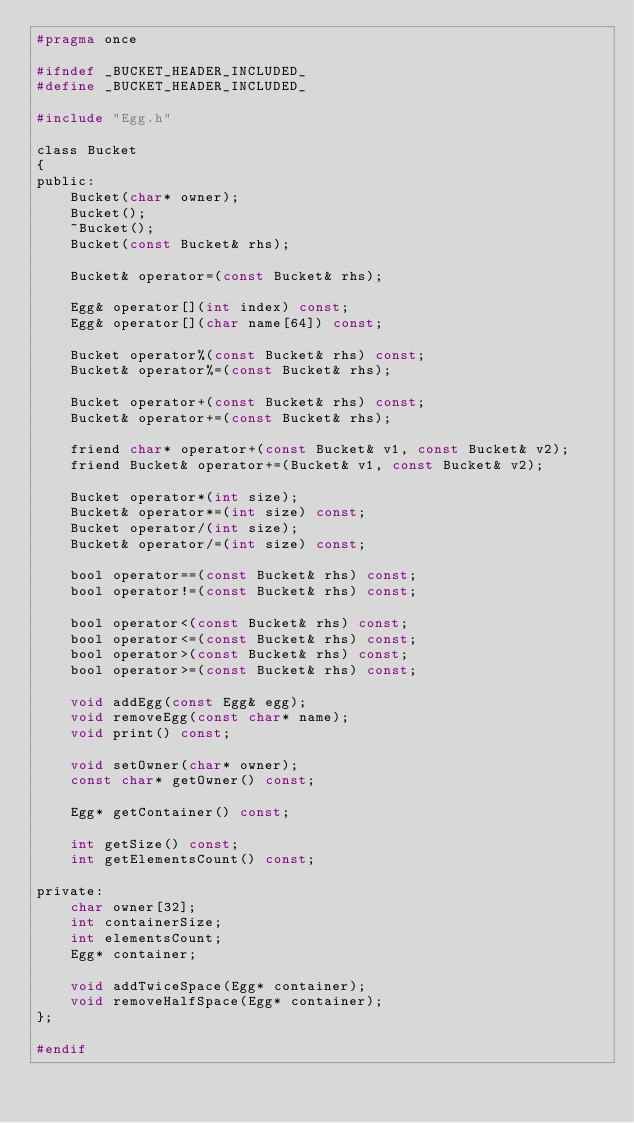<code> <loc_0><loc_0><loc_500><loc_500><_C_>#pragma once

#ifndef _BUCKET_HEADER_INCLUDED_
#define _BUCKET_HEADER_INCLUDED_

#include "Egg.h"

class Bucket
{
public:
	Bucket(char* owner);
	Bucket();
	~Bucket();
	Bucket(const Bucket& rhs);

	Bucket& operator=(const Bucket& rhs);

	Egg& operator[](int index) const;
	Egg& operator[](char name[64]) const;

	Bucket operator%(const Bucket& rhs) const;
	Bucket& operator%=(const Bucket& rhs);

	Bucket operator+(const Bucket& rhs) const;
	Bucket& operator+=(const Bucket& rhs);

	friend char* operator+(const Bucket& v1, const Bucket& v2);
	friend Bucket& operator+=(Bucket& v1, const Bucket& v2);

	Bucket operator*(int size);
	Bucket& operator*=(int size) const;
	Bucket operator/(int size);
	Bucket& operator/=(int size) const;

	bool operator==(const Bucket& rhs) const;
	bool operator!=(const Bucket& rhs) const;

	bool operator<(const Bucket& rhs) const;
	bool operator<=(const Bucket& rhs) const;
	bool operator>(const Bucket& rhs) const;
	bool operator>=(const Bucket& rhs) const;

	void addEgg(const Egg& egg);
	void removeEgg(const char* name);
	void print() const;

	void setOwner(char* owner);
	const char* getOwner() const;

	Egg* getContainer() const;

	int getSize() const;
	int getElementsCount() const;

private:
	char owner[32];
	int containerSize;
	int elementsCount;
	Egg* container;

	void addTwiceSpace(Egg* container);
	void removeHalfSpace(Egg* container);
};

#endif
</code> 